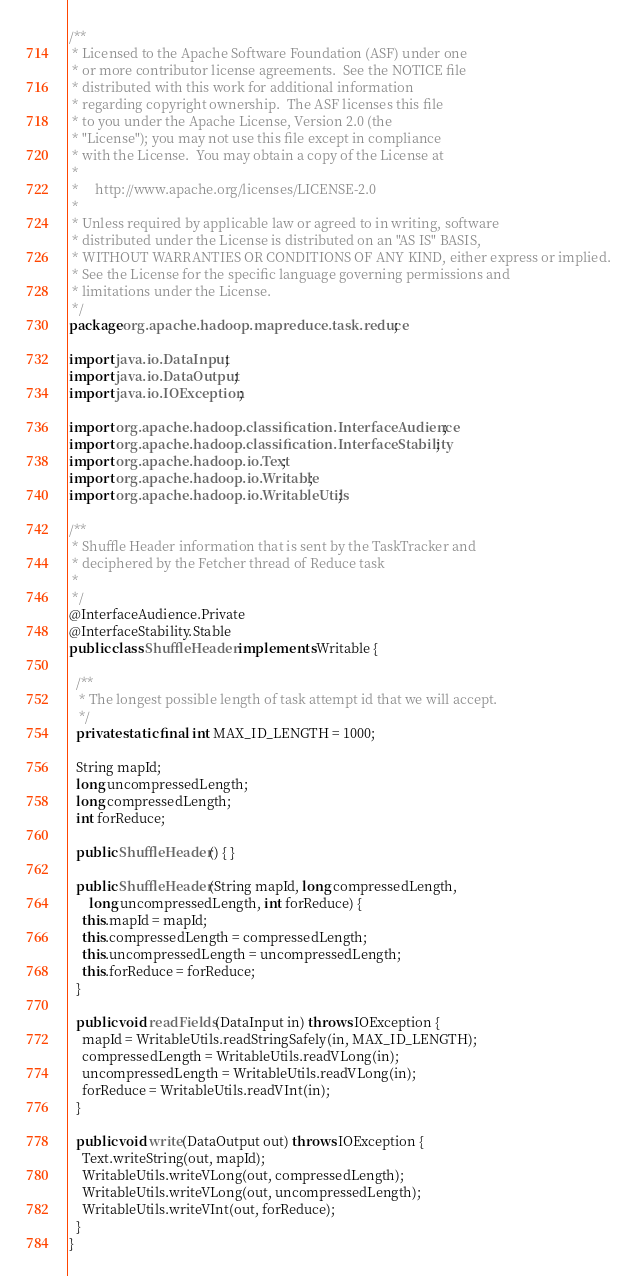Convert code to text. <code><loc_0><loc_0><loc_500><loc_500><_Java_>/**
 * Licensed to the Apache Software Foundation (ASF) under one
 * or more contributor license agreements.  See the NOTICE file
 * distributed with this work for additional information
 * regarding copyright ownership.  The ASF licenses this file
 * to you under the Apache License, Version 2.0 (the
 * "License"); you may not use this file except in compliance
 * with the License.  You may obtain a copy of the License at
 *
 *     http://www.apache.org/licenses/LICENSE-2.0
 *
 * Unless required by applicable law or agreed to in writing, software
 * distributed under the License is distributed on an "AS IS" BASIS,
 * WITHOUT WARRANTIES OR CONDITIONS OF ANY KIND, either express or implied.
 * See the License for the specific language governing permissions and
 * limitations under the License.
 */
package org.apache.hadoop.mapreduce.task.reduce;

import java.io.DataInput;
import java.io.DataOutput;
import java.io.IOException;

import org.apache.hadoop.classification.InterfaceAudience;
import org.apache.hadoop.classification.InterfaceStability;
import org.apache.hadoop.io.Text;
import org.apache.hadoop.io.Writable;
import org.apache.hadoop.io.WritableUtils;

/**
 * Shuffle Header information that is sent by the TaskTracker and 
 * deciphered by the Fetcher thread of Reduce task
 *
 */
@InterfaceAudience.Private
@InterfaceStability.Stable
public class ShuffleHeader implements Writable {

  /**
   * The longest possible length of task attempt id that we will accept.
   */
  private static final int MAX_ID_LENGTH = 1000;

  String mapId;
  long uncompressedLength;
  long compressedLength;
  int forReduce;
  
  public ShuffleHeader() { }
  
  public ShuffleHeader(String mapId, long compressedLength,
      long uncompressedLength, int forReduce) {
    this.mapId = mapId;
    this.compressedLength = compressedLength;
    this.uncompressedLength = uncompressedLength;
    this.forReduce = forReduce;
  }
  
  public void readFields(DataInput in) throws IOException {
    mapId = WritableUtils.readStringSafely(in, MAX_ID_LENGTH);
    compressedLength = WritableUtils.readVLong(in);
    uncompressedLength = WritableUtils.readVLong(in);
    forReduce = WritableUtils.readVInt(in);
  }

  public void write(DataOutput out) throws IOException {
    Text.writeString(out, mapId);
    WritableUtils.writeVLong(out, compressedLength);
    WritableUtils.writeVLong(out, uncompressedLength);
    WritableUtils.writeVInt(out, forReduce);
  }
}</code> 